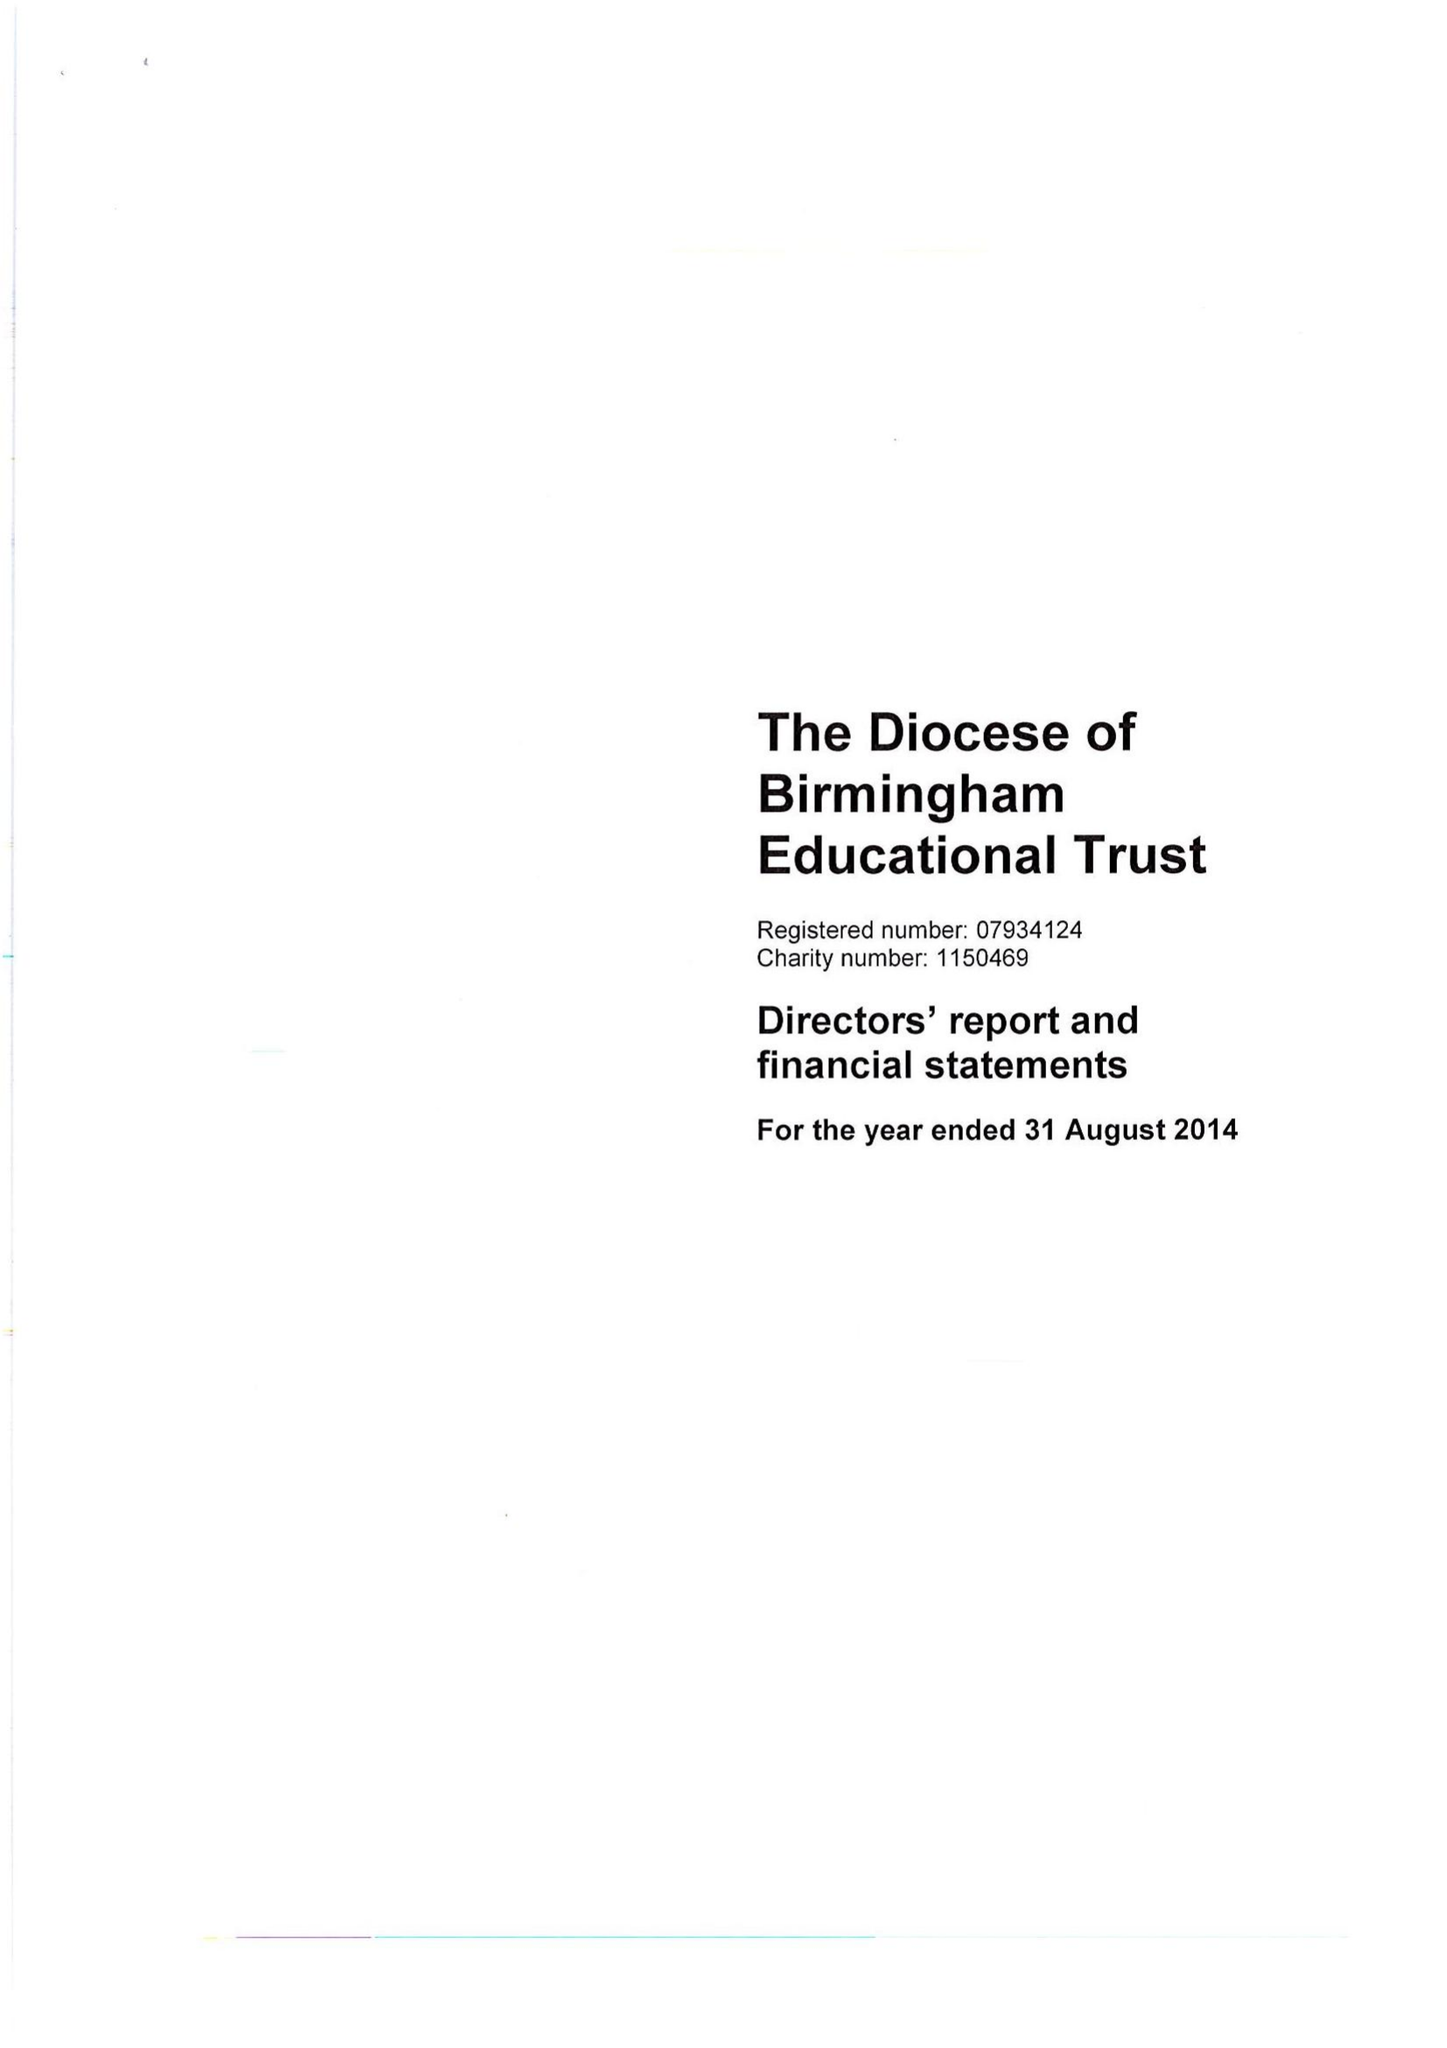What is the value for the spending_annually_in_british_pounds?
Answer the question using a single word or phrase. 269703.00 